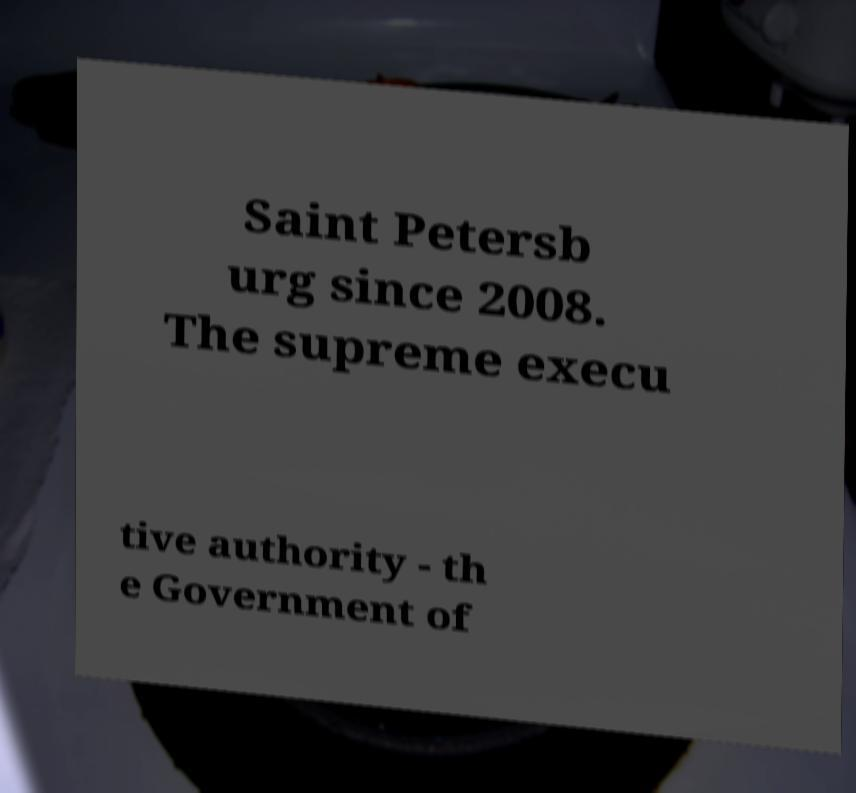What messages or text are displayed in this image? I need them in a readable, typed format. Saint Petersb urg since 2008. The supreme execu tive authority - th e Government of 